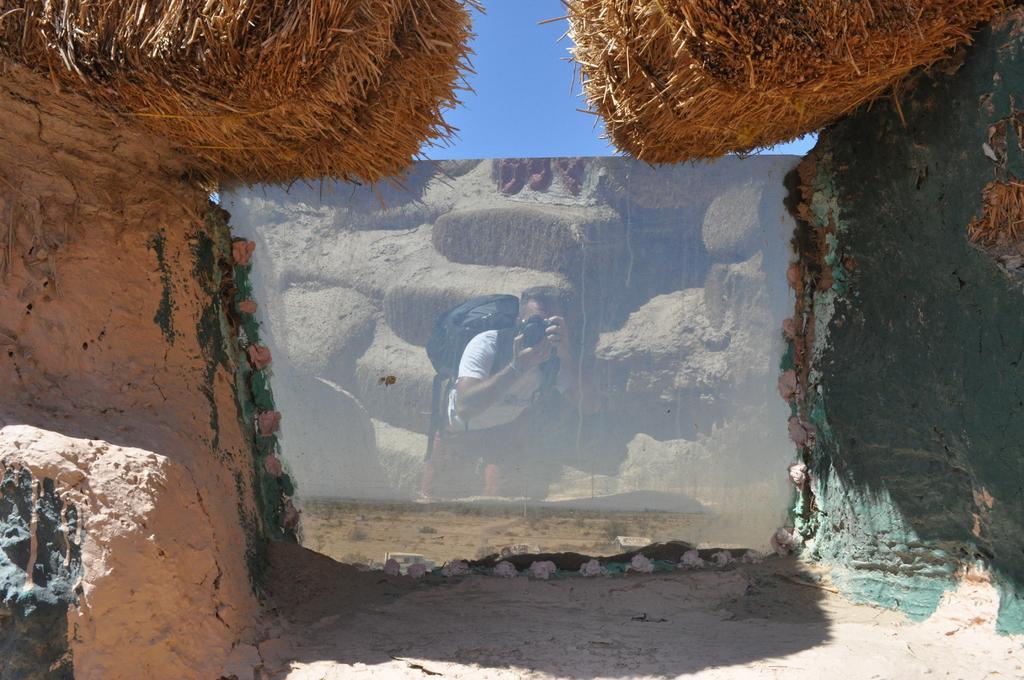Could you give a brief overview of what you see in this image? In the foreground of the picture we can see rocks, mirror like object and dry grass. In the mirror we can see the reflection of a person holding camera. At the top it is sky. 